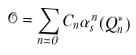Convert formula to latex. <formula><loc_0><loc_0><loc_500><loc_500>\mathcal { O } = \sum _ { n = 0 } C _ { n } \alpha ^ { n } _ { s } ( Q ^ { * } _ { n } )</formula> 